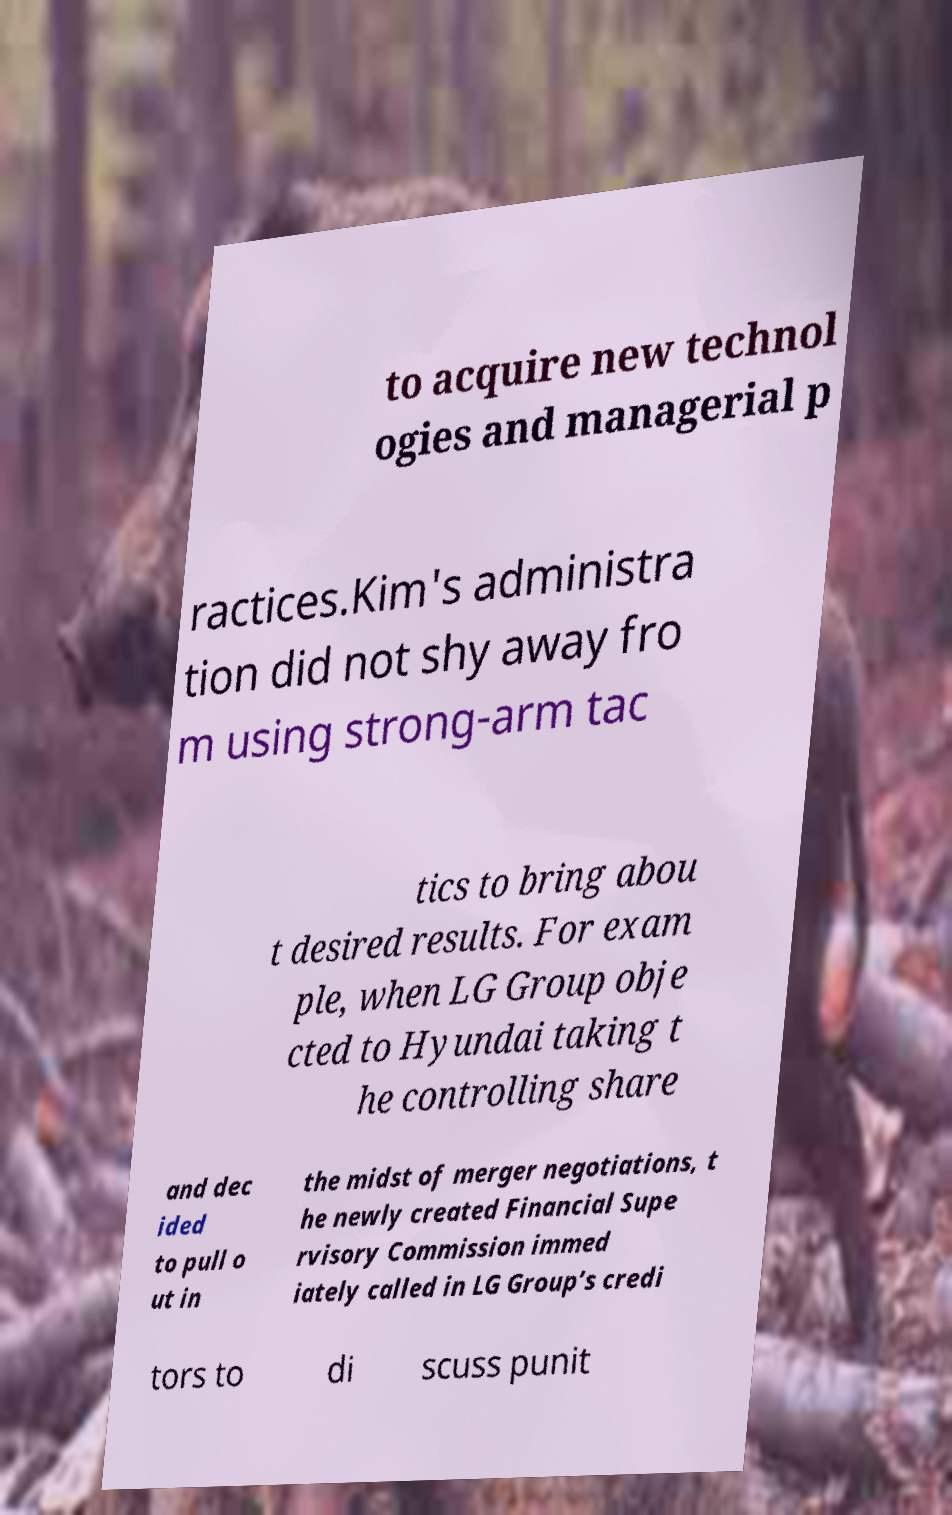Can you read and provide the text displayed in the image?This photo seems to have some interesting text. Can you extract and type it out for me? to acquire new technol ogies and managerial p ractices.Kim's administra tion did not shy away fro m using strong-arm tac tics to bring abou t desired results. For exam ple, when LG Group obje cted to Hyundai taking t he controlling share and dec ided to pull o ut in the midst of merger negotiations, t he newly created Financial Supe rvisory Commission immed iately called in LG Group’s credi tors to di scuss punit 